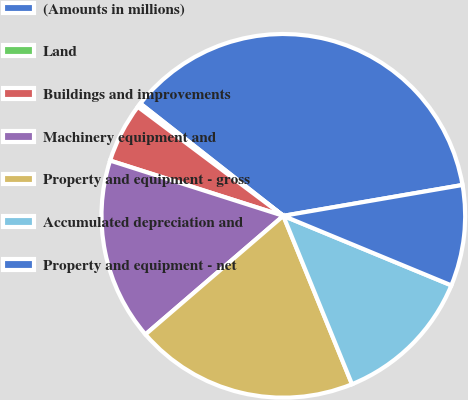<chart> <loc_0><loc_0><loc_500><loc_500><pie_chart><fcel>(Amounts in millions)<fcel>Land<fcel>Buildings and improvements<fcel>Machinery equipment and<fcel>Property and equipment - gross<fcel>Accumulated depreciation and<fcel>Property and equipment - net<nl><fcel>36.69%<fcel>0.36%<fcel>5.32%<fcel>16.22%<fcel>19.86%<fcel>12.59%<fcel>8.96%<nl></chart> 